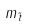<formula> <loc_0><loc_0><loc_500><loc_500>m _ { \tilde { t } }</formula> 